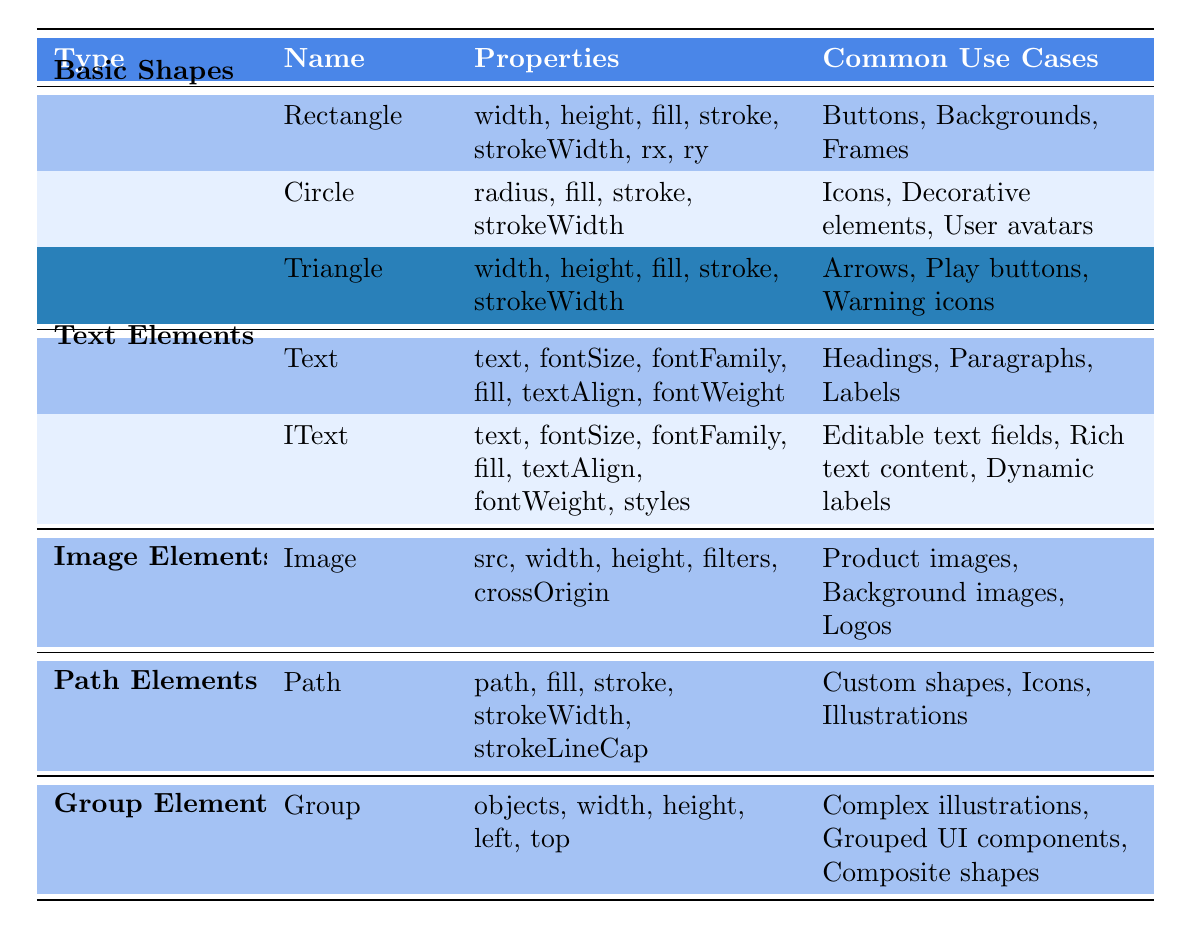What types of elements are included in the Fabric.js table? The table lists five types of elements: Basic Shapes, Text Elements, Image Elements, Path Elements, and Group Elements.
Answer: Five What properties are associated with the Circle element? The properties for the Circle element are radius, fill, stroke, and strokeWidth.
Answer: Radius, fill, stroke, strokeWidth How many properties are listed for the IText element? The IText element has seven properties: text, fontSize, fontFamily, fill, textAlign, fontWeight, and styles, which totals to seven.
Answer: Seven Is "Stroke" a common property for the Rectangle element? Yes, "stroke" is one of the properties listed for the Rectangle element.
Answer: Yes Which element types can be used to create buttons? The Rectangle element is listed under Basic Shapes, and it's commonly used for buttons.
Answer: Rectangle Which element has the most common use cases? The Image element has three common use cases listed under it, comparing with other elements which generally have three as well, but it also indicates versatility.
Answer: Image If I wanted to create dynamic labels, which element would be appropriate? The IText element is specifically mentioned for dynamic labels among its common use cases.
Answer: IText What is the common use case for the Triangle element? The Triangle element is commonly used for arrows, play buttons, and warning icons.
Answer: Arrows, play buttons, warning icons If you wanted to create complex illustrations, which type of element would you use? You would use the Group element as it is specifically listed for creating complex illustrations.
Answer: Group How many total elements are listed under Basic Shapes? There are three elements listed under Basic Shapes: Rectangle, Circle, and Triangle. Thus, the total count is three.
Answer: Three 